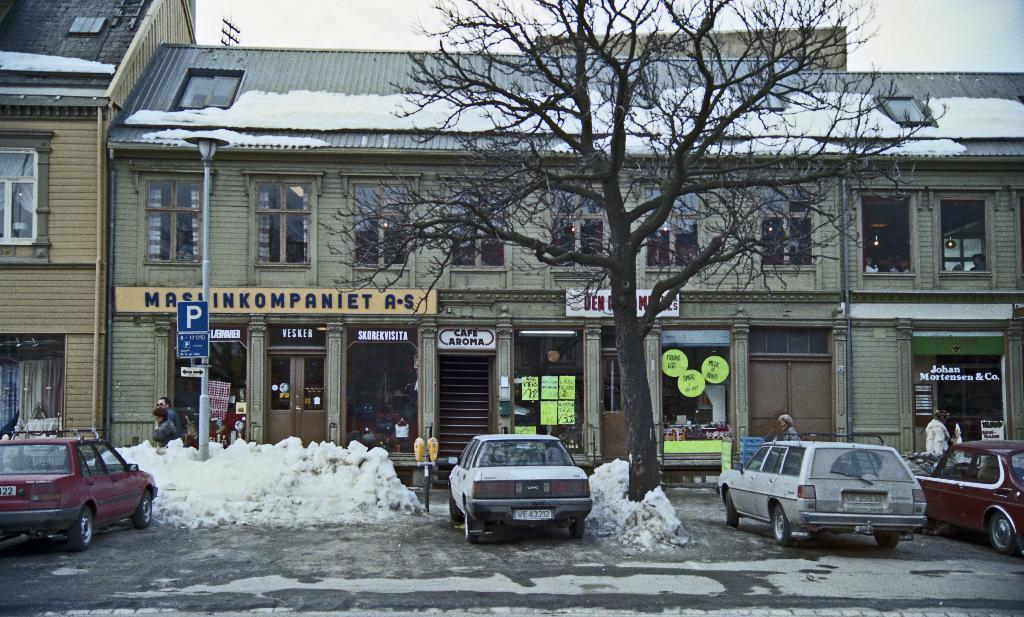What can be seen in front of the building in the image? There are cars parked in front of the building. What is located in the middle of the image? There is a tree in the middle of the image. What is covering the top of the building? There is snow on the top of the building. What type of wool is being used to make the kittens' sweaters in the image? There are no kittens or sweaters present in the image, so it is not possible to determine the type of wool being used. 